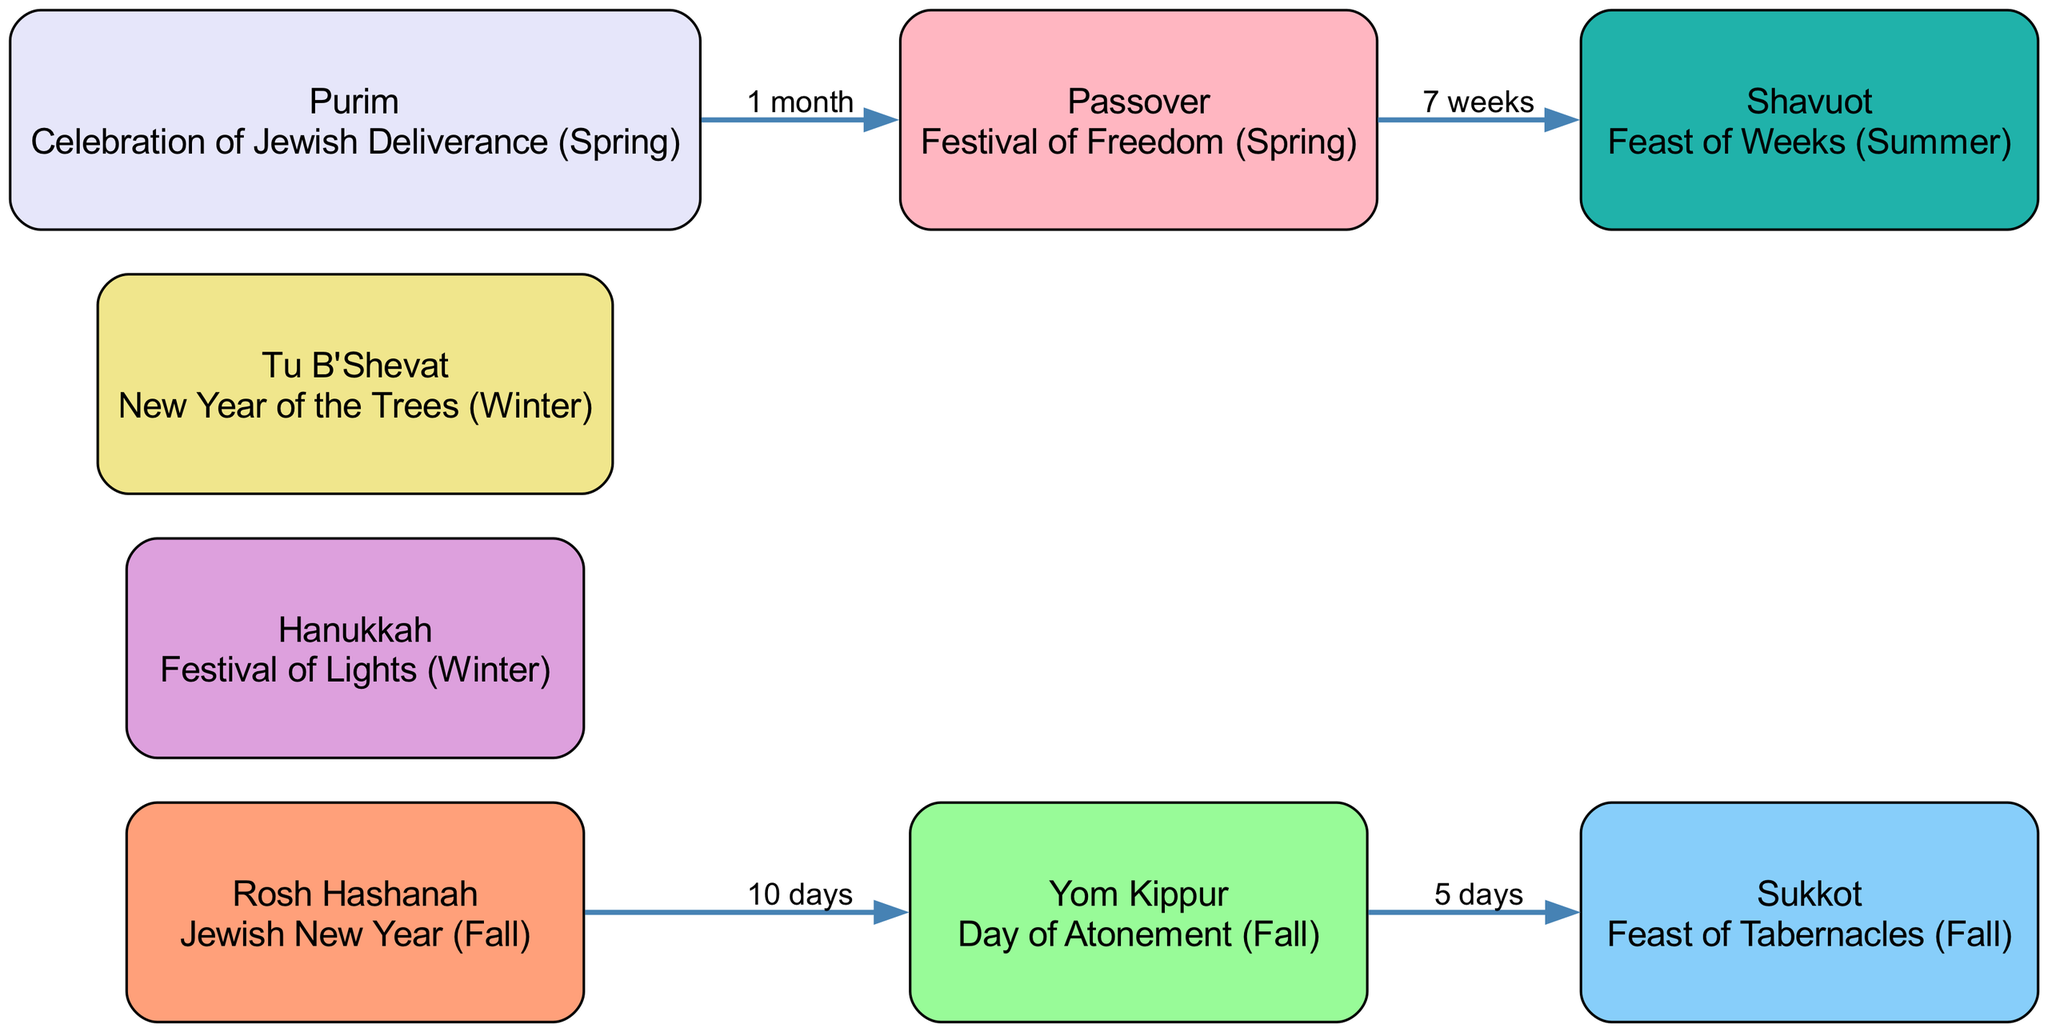What is the first holiday in the diagram? The first holiday listed in the blocks is Rosh Hashanah, which is clearly stated at the top of the diagram.
Answer: Rosh Hashanah How many major holidays are depicted in the diagram? By counting the unique blocks labeled as holidays, there are 8 major holidays represented.
Answer: 8 What is the holiday celebrated after Yom Kippur? The diagram shows that the next holiday after Yom Kippur is Sukkot, as indicated by the flow from one to the other.
Answer: Sukkot What period separates Rosh Hashanah and Yom Kippur? The diagram specifies that there is a 10-day relationship between Rosh Hashanah and Yom Kippur, as indicated along the connecting arrow.
Answer: 10 days Which holiday follows Passover in the lifecycle? According to the diagram, Shavuot follows Passover, shown by the connection leading from Passover to Shavuot.
Answer: Shavuot What holiday occurs in the winter season? The diagram lists Hanukkah and Tu B'Shevat as the holidays that occur in the winter, identified by their descriptions within the blocks.
Answer: Hanukkah, Tu B'Shevat What is the connection between Purim and Passover? The diagram indicates that Purim is celebrated 1 month before Passover, highlighted by the labeled arrow connecting the two holidays.
Answer: 1 month Which holiday's description includes the word "deliverance"? The description for Purim includes the word "Deliverance," as this is where the celebration is clearly defined.
Answer: Purim What is the total number of connections between the holidays? The diagram shows a total of 4 connections, which can be counted from the number of labeled arrows connecting the blocks.
Answer: 4 